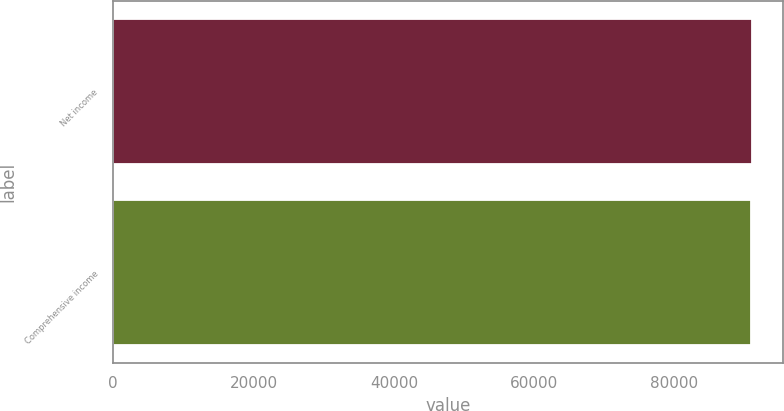Convert chart to OTSL. <chart><loc_0><loc_0><loc_500><loc_500><bar_chart><fcel>Net income<fcel>Comprehensive income<nl><fcel>91008<fcel>90997<nl></chart> 